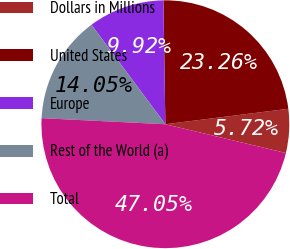Convert chart. <chart><loc_0><loc_0><loc_500><loc_500><pie_chart><fcel>Dollars in Millions<fcel>United States<fcel>Europe<fcel>Rest of the World (a)<fcel>Total<nl><fcel>5.72%<fcel>23.26%<fcel>9.92%<fcel>14.05%<fcel>47.05%<nl></chart> 